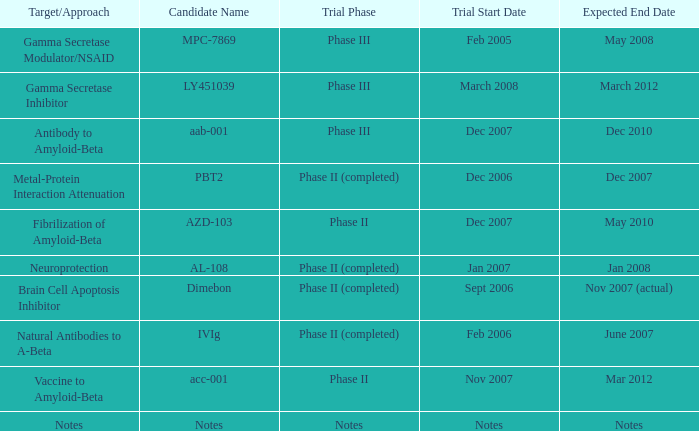What is Candidate Name, when Target/Approach is "vaccine to amyloid-beta"? Acc-001. 